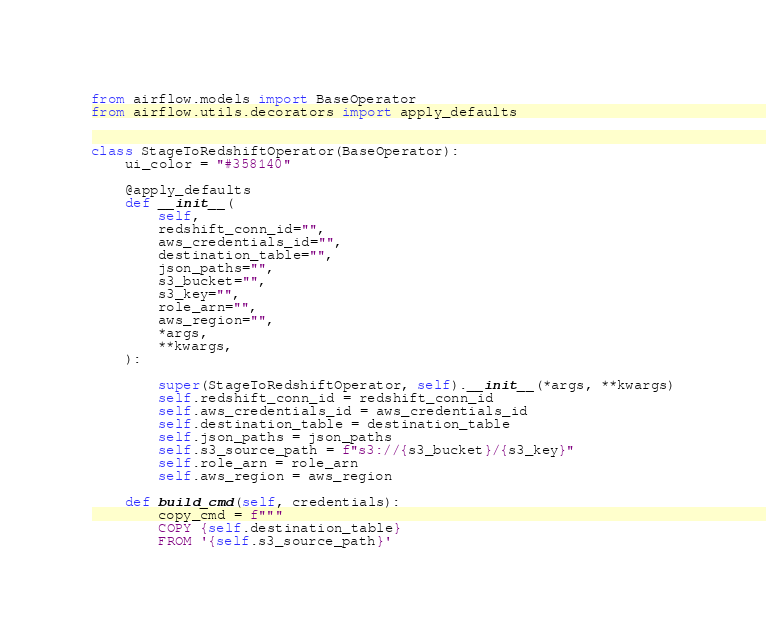Convert code to text. <code><loc_0><loc_0><loc_500><loc_500><_Python_>from airflow.models import BaseOperator
from airflow.utils.decorators import apply_defaults


class StageToRedshiftOperator(BaseOperator):
    ui_color = "#358140"

    @apply_defaults
    def __init__(
        self,
        redshift_conn_id="",
        aws_credentials_id="",
        destination_table="",
        json_paths="",
        s3_bucket="",
        s3_key="",
        role_arn="",
        aws_region="",
        *args,
        **kwargs,
    ):

        super(StageToRedshiftOperator, self).__init__(*args, **kwargs)
        self.redshift_conn_id = redshift_conn_id
        self.aws_credentials_id = aws_credentials_id
        self.destination_table = destination_table
        self.json_paths = json_paths
        self.s3_source_path = f"s3://{s3_bucket}/{s3_key}"
        self.role_arn = role_arn
        self.aws_region = aws_region

    def build_cmd(self, credentials):
        copy_cmd = f"""
        COPY {self.destination_table}
        FROM '{self.s3_source_path}'</code> 